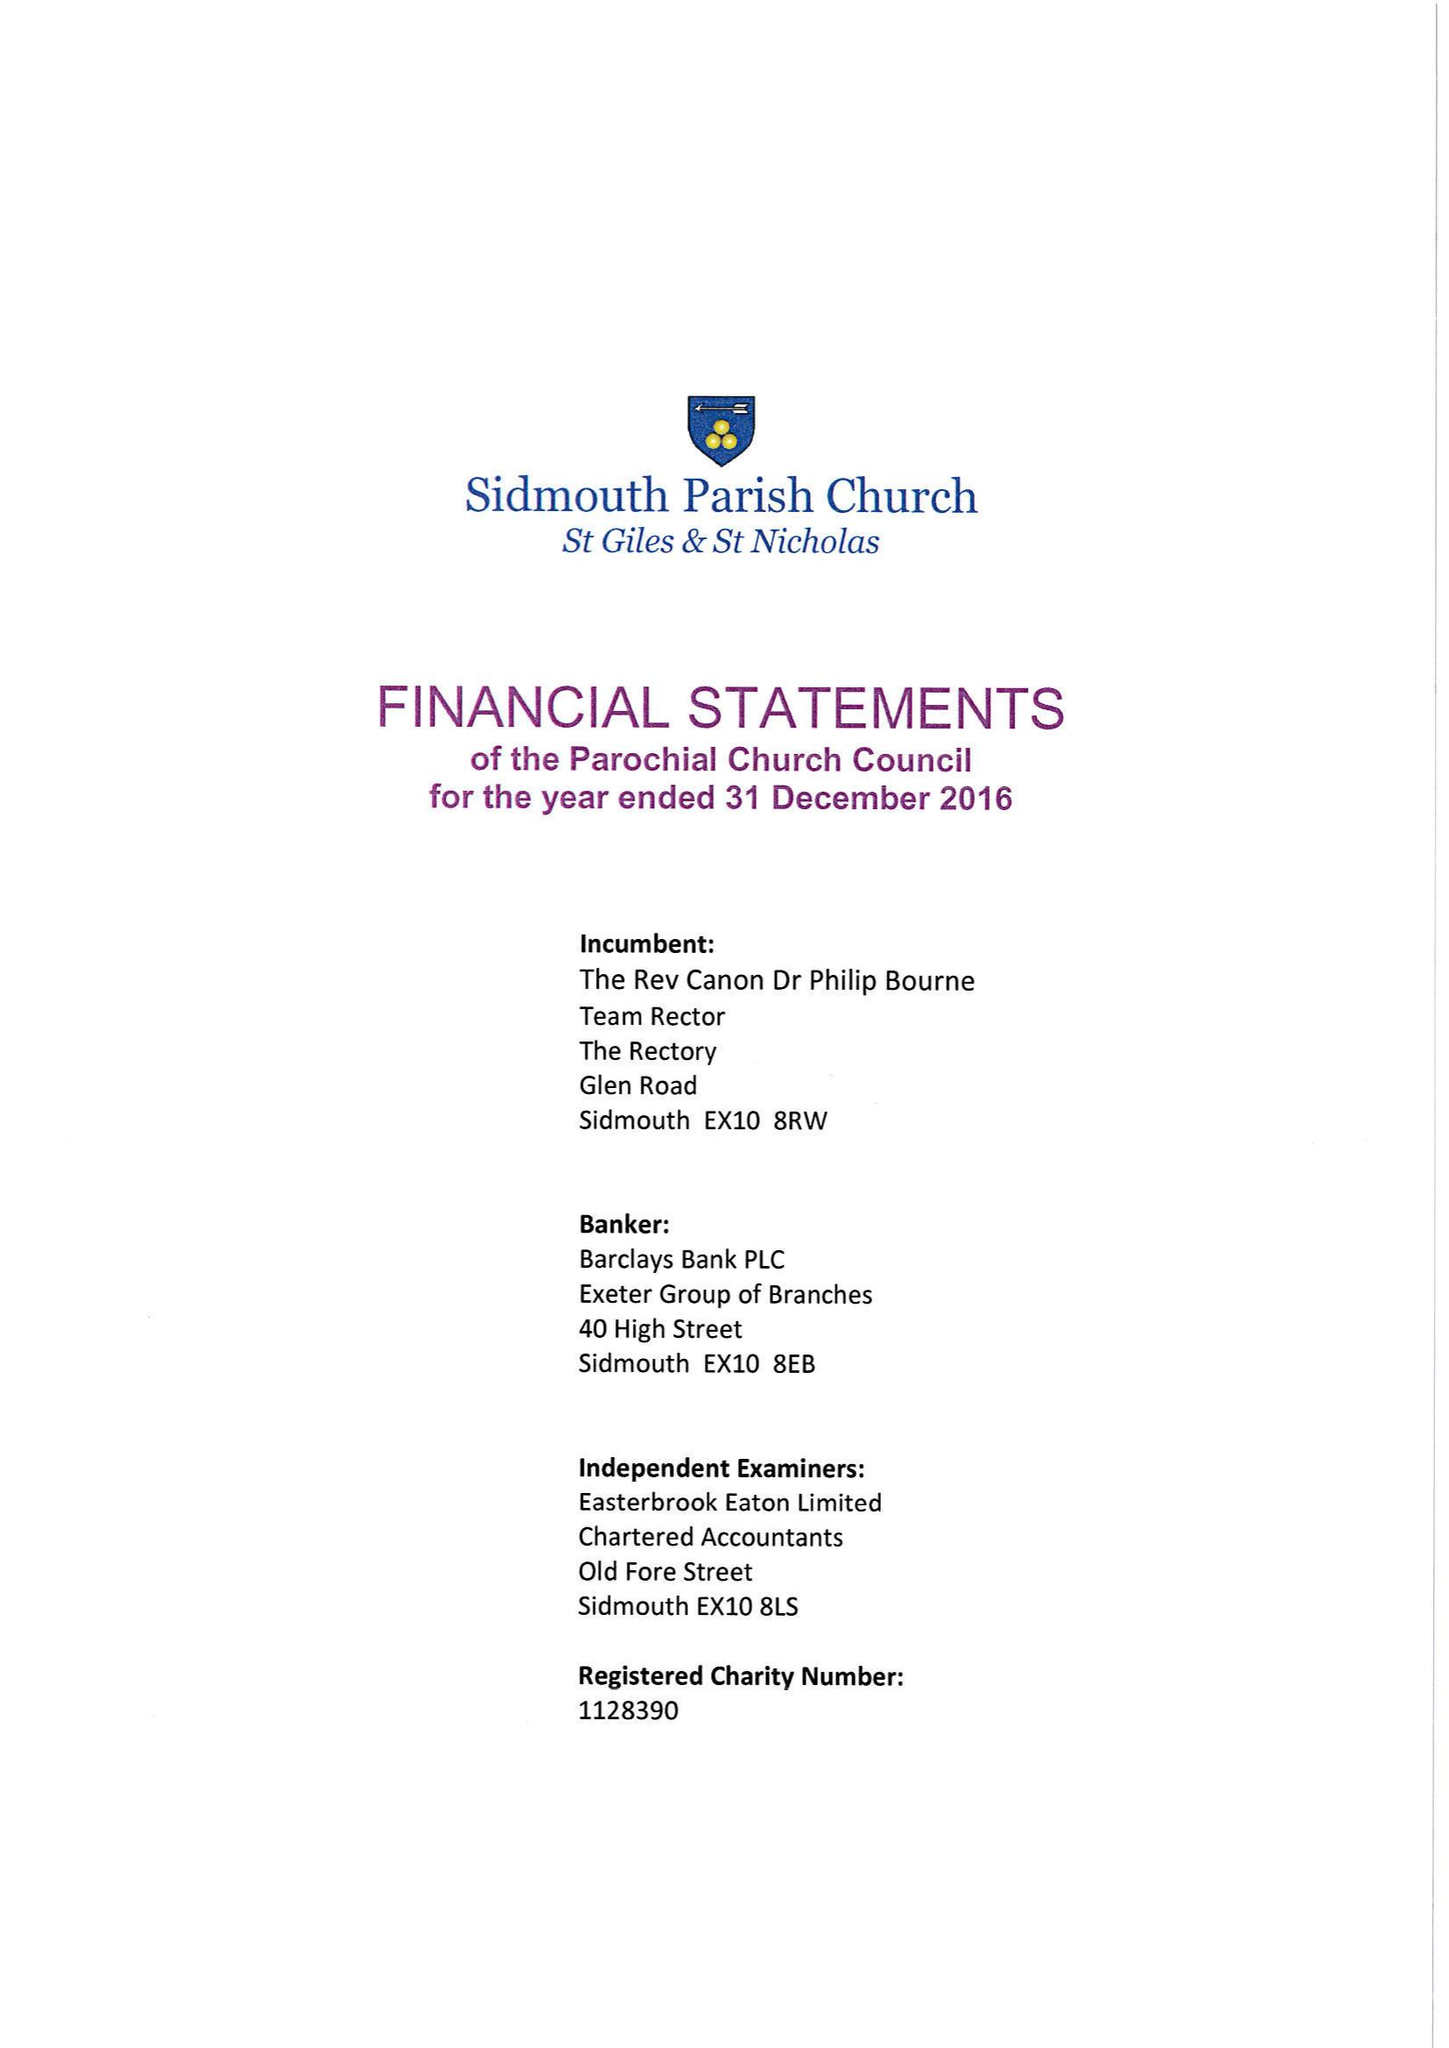What is the value for the income_annually_in_british_pounds?
Answer the question using a single word or phrase. 306667.00 